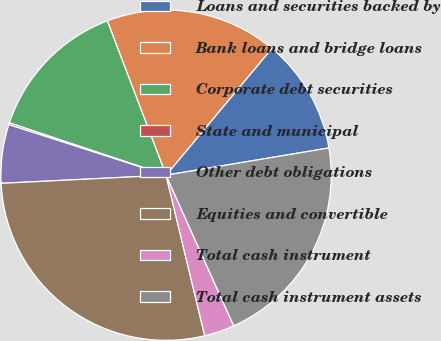Convert chart. <chart><loc_0><loc_0><loc_500><loc_500><pie_chart><fcel>Loans and securities backed by<fcel>Bank loans and bridge loans<fcel>Corporate debt securities<fcel>State and municipal<fcel>Other debt obligations<fcel>Equities and convertible<fcel>Total cash instrument<fcel>Total cash instrument assets<nl><fcel>11.3%<fcel>16.86%<fcel>14.08%<fcel>0.18%<fcel>5.74%<fcel>27.98%<fcel>2.96%<fcel>20.92%<nl></chart> 